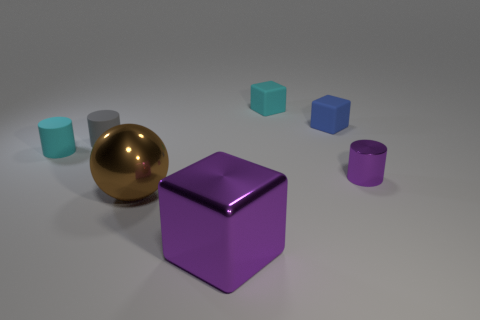Can you describe the texture of the objects? Certainly! The objects display two distinct textures. The spheres have a smooth, reflective surface, while the cubes appear to have a slightly matte finish, giving them a softer appearance. 